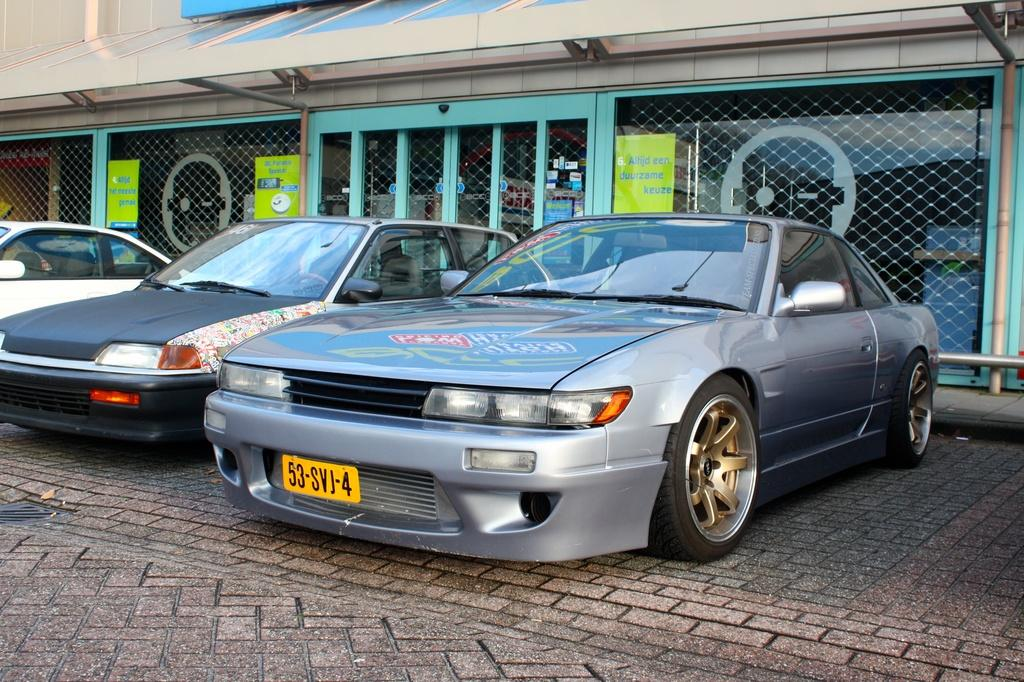How many cars can be seen on the road in the image? There are three cars on the road in the image. What can be seen in the background of the image? There is a building, boards, a fence, metal rods, and a wall in the background of the image. What might indicate the time of day the day when the image was taken? The image is likely taken during the day, as there is no indication of darkness or artificial lighting. How many jellyfish can be seen on the roof in the image? There are no jellyfish or roof present in the image. 